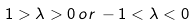<formula> <loc_0><loc_0><loc_500><loc_500>1 > \lambda > 0 \, o r \, - 1 < \lambda < 0</formula> 